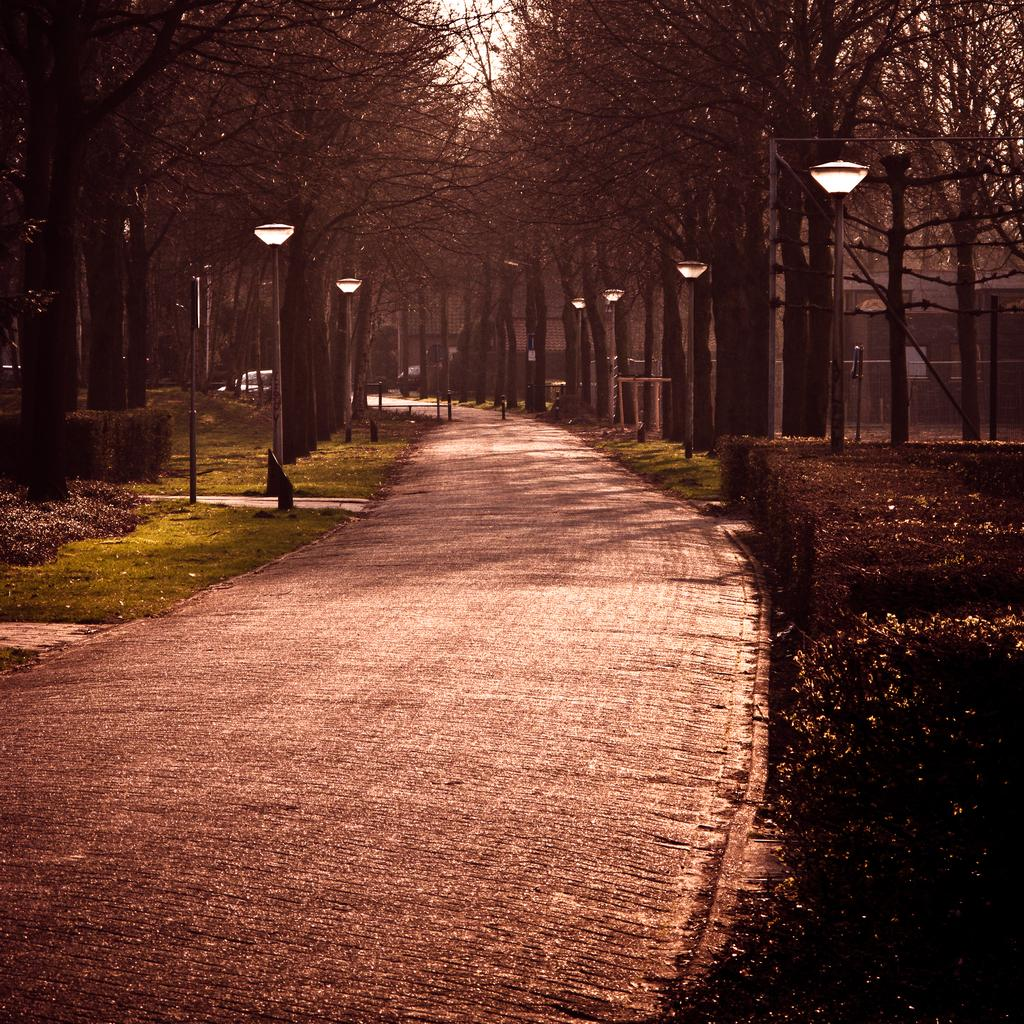What structures are present in the image? There are poles and lights in the image. What type of terrain is visible in the image? There is grass in the image. Is there a designated walking area in the image? Yes, there is a path in the image. What can be seen in the background of the image? There are trees in the background of the image. What is the name of the person walking on the path in the image? There is no person walking on the path in the image, so it is not possible to determine their name. 